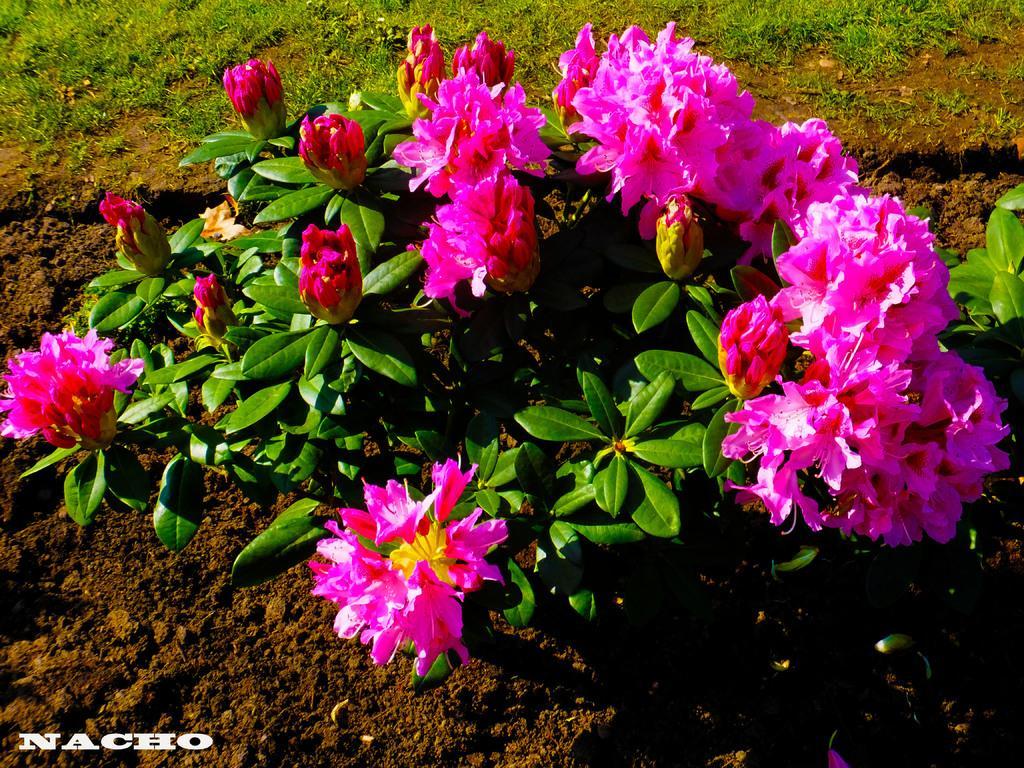Please provide a concise description of this image. In this image we can see there are plants with flowers and grass. 